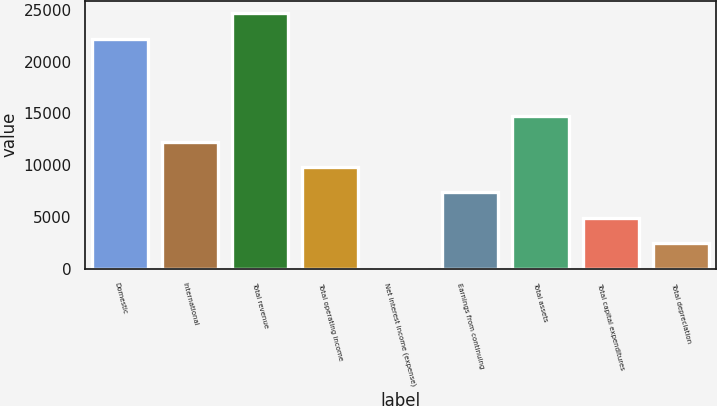Convert chart to OTSL. <chart><loc_0><loc_0><loc_500><loc_500><bar_chart><fcel>Domestic<fcel>International<fcel>Total revenue<fcel>Total operating income<fcel>Net interest income (expense)<fcel>Earnings from continuing<fcel>Total assets<fcel>Total capital expenditures<fcel>Total depreciation<nl><fcel>22225<fcel>12278<fcel>24679<fcel>9824<fcel>8<fcel>7370<fcel>14732<fcel>4916<fcel>2462<nl></chart> 